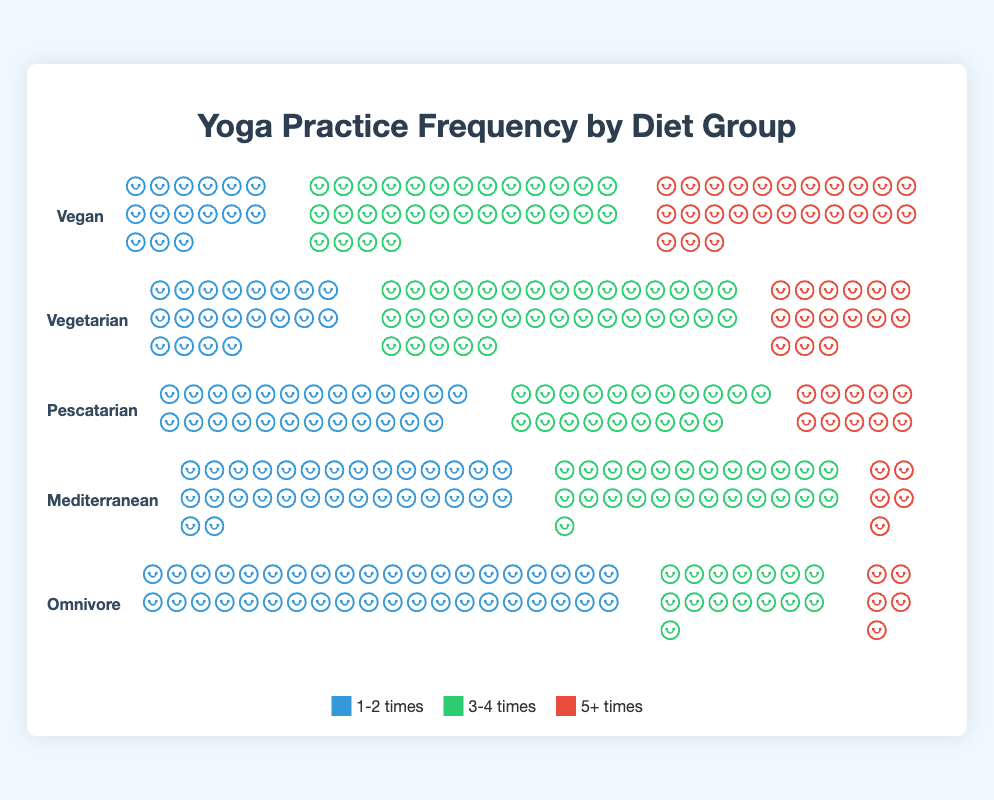Which diet group has the highest count of people practicing yoga 1-2 times a week? The chart indicates the number of people practicing yoga 1-2 times a week for each diet group. The highest count is for the Omnivore group, which has 40 people practicing yoga 1-2 times a week.
Answer: Omnivore Which diet group shows the most balanced practice frequencies across all categories (1-2 times, 3-4 times, and 5+ times)? We need to compare the spread of counts across practice frequencies for each diet group. The Vegan group has a relatively balanced distribution with 15, 30, and 25 people practicing 1-2 times, 3-4 times, and 5+ times per week, respectively.
Answer: Vegan How many more people practice yoga 3-4 times a week compared to 1-2 times a week in the Vegetarian group? The Vegetarian group has 35 people practicing 3-4 times and 20 people practicing 1-2 times. The difference is 35 - 20 = 15.
Answer: 15 Which diet group has the lowest count of people practicing yoga 5+ times a week? By comparing the number of people practicing yoga 5+ times a week across all diet groups, the Mediterranean group has the lowest count with 5 people.
Answer: Mediterranean For the Pescatarian group, how many total yoga sessions are practiced by people practicing 1-2 times and 3-4 times a week? The chart shows 25 people practicing 1-2 times and 20 people practicing 3-4 times. Summing these counts gives 25 + 20 = 45.
Answer: 45 Compare the number of people practicing yoga 5+ times a week between the Vegan and Vegetarian groups. Which group has more people, and by how many? The Vegan group has 25 people practicing yoga 5+ times a week, while the Vegetarian group has 15. Thus, the Vegan group has 25 - 15 = 10 more people practicing 5+ times a week.
Answer: Vegan, by 10 Which diet group has the highest total count of yoga practice sessions in a week when combining all frequency categories? Summing the counts for all frequency categories: Vegan (15 + 30 + 25 = 70), Vegetarian (20 + 35 + 15 = 70), Pescatarian (25 + 20 + 10 = 55), Mediterranean (30 + 25 + 5 = 60), Omnivore (40 + 15 + 5 = 60). Both Vegan and Vegetarian groups have the highest total with 70 each.
Answer: Vegan and Vegetarian Which practice frequency category has the highest count within the Omnivore group? The Omnivore group's highest count is in the 1-2 times category, with 40 people.
Answer: 1-2 times What is the average count of people practicing yoga 3-4 times a week across all diet groups? To find the average, sum the counts for 3-4 times from all diet groups and divide by the number of groups: (30 + 35 + 20 + 25 + 15) / 5 = 125 / 5 = 25.
Answer: 25 